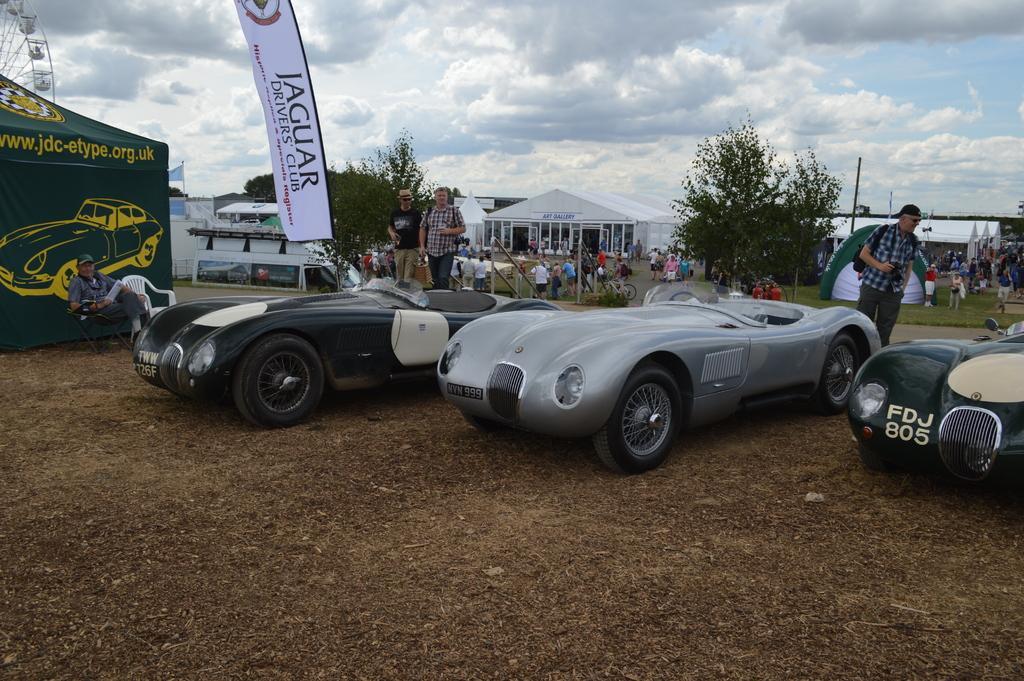How would you summarize this image in a sentence or two? In this image we can see one green color tent with car image and some text on it. There are so many people, one flag, some people are holding some objects, some tents, some houses, some objects are on the surface, some trees, three cars, some bicycles, one Giant wheel, some banners and at the top there is the cloudy sky. 